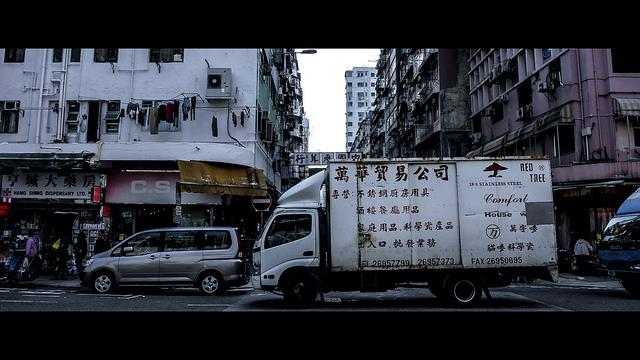Why does the large truck stop here? delivery 